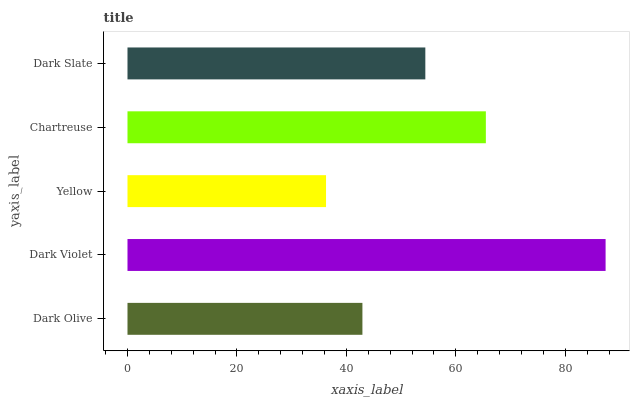Is Yellow the minimum?
Answer yes or no. Yes. Is Dark Violet the maximum?
Answer yes or no. Yes. Is Dark Violet the minimum?
Answer yes or no. No. Is Yellow the maximum?
Answer yes or no. No. Is Dark Violet greater than Yellow?
Answer yes or no. Yes. Is Yellow less than Dark Violet?
Answer yes or no. Yes. Is Yellow greater than Dark Violet?
Answer yes or no. No. Is Dark Violet less than Yellow?
Answer yes or no. No. Is Dark Slate the high median?
Answer yes or no. Yes. Is Dark Slate the low median?
Answer yes or no. Yes. Is Dark Violet the high median?
Answer yes or no. No. Is Yellow the low median?
Answer yes or no. No. 